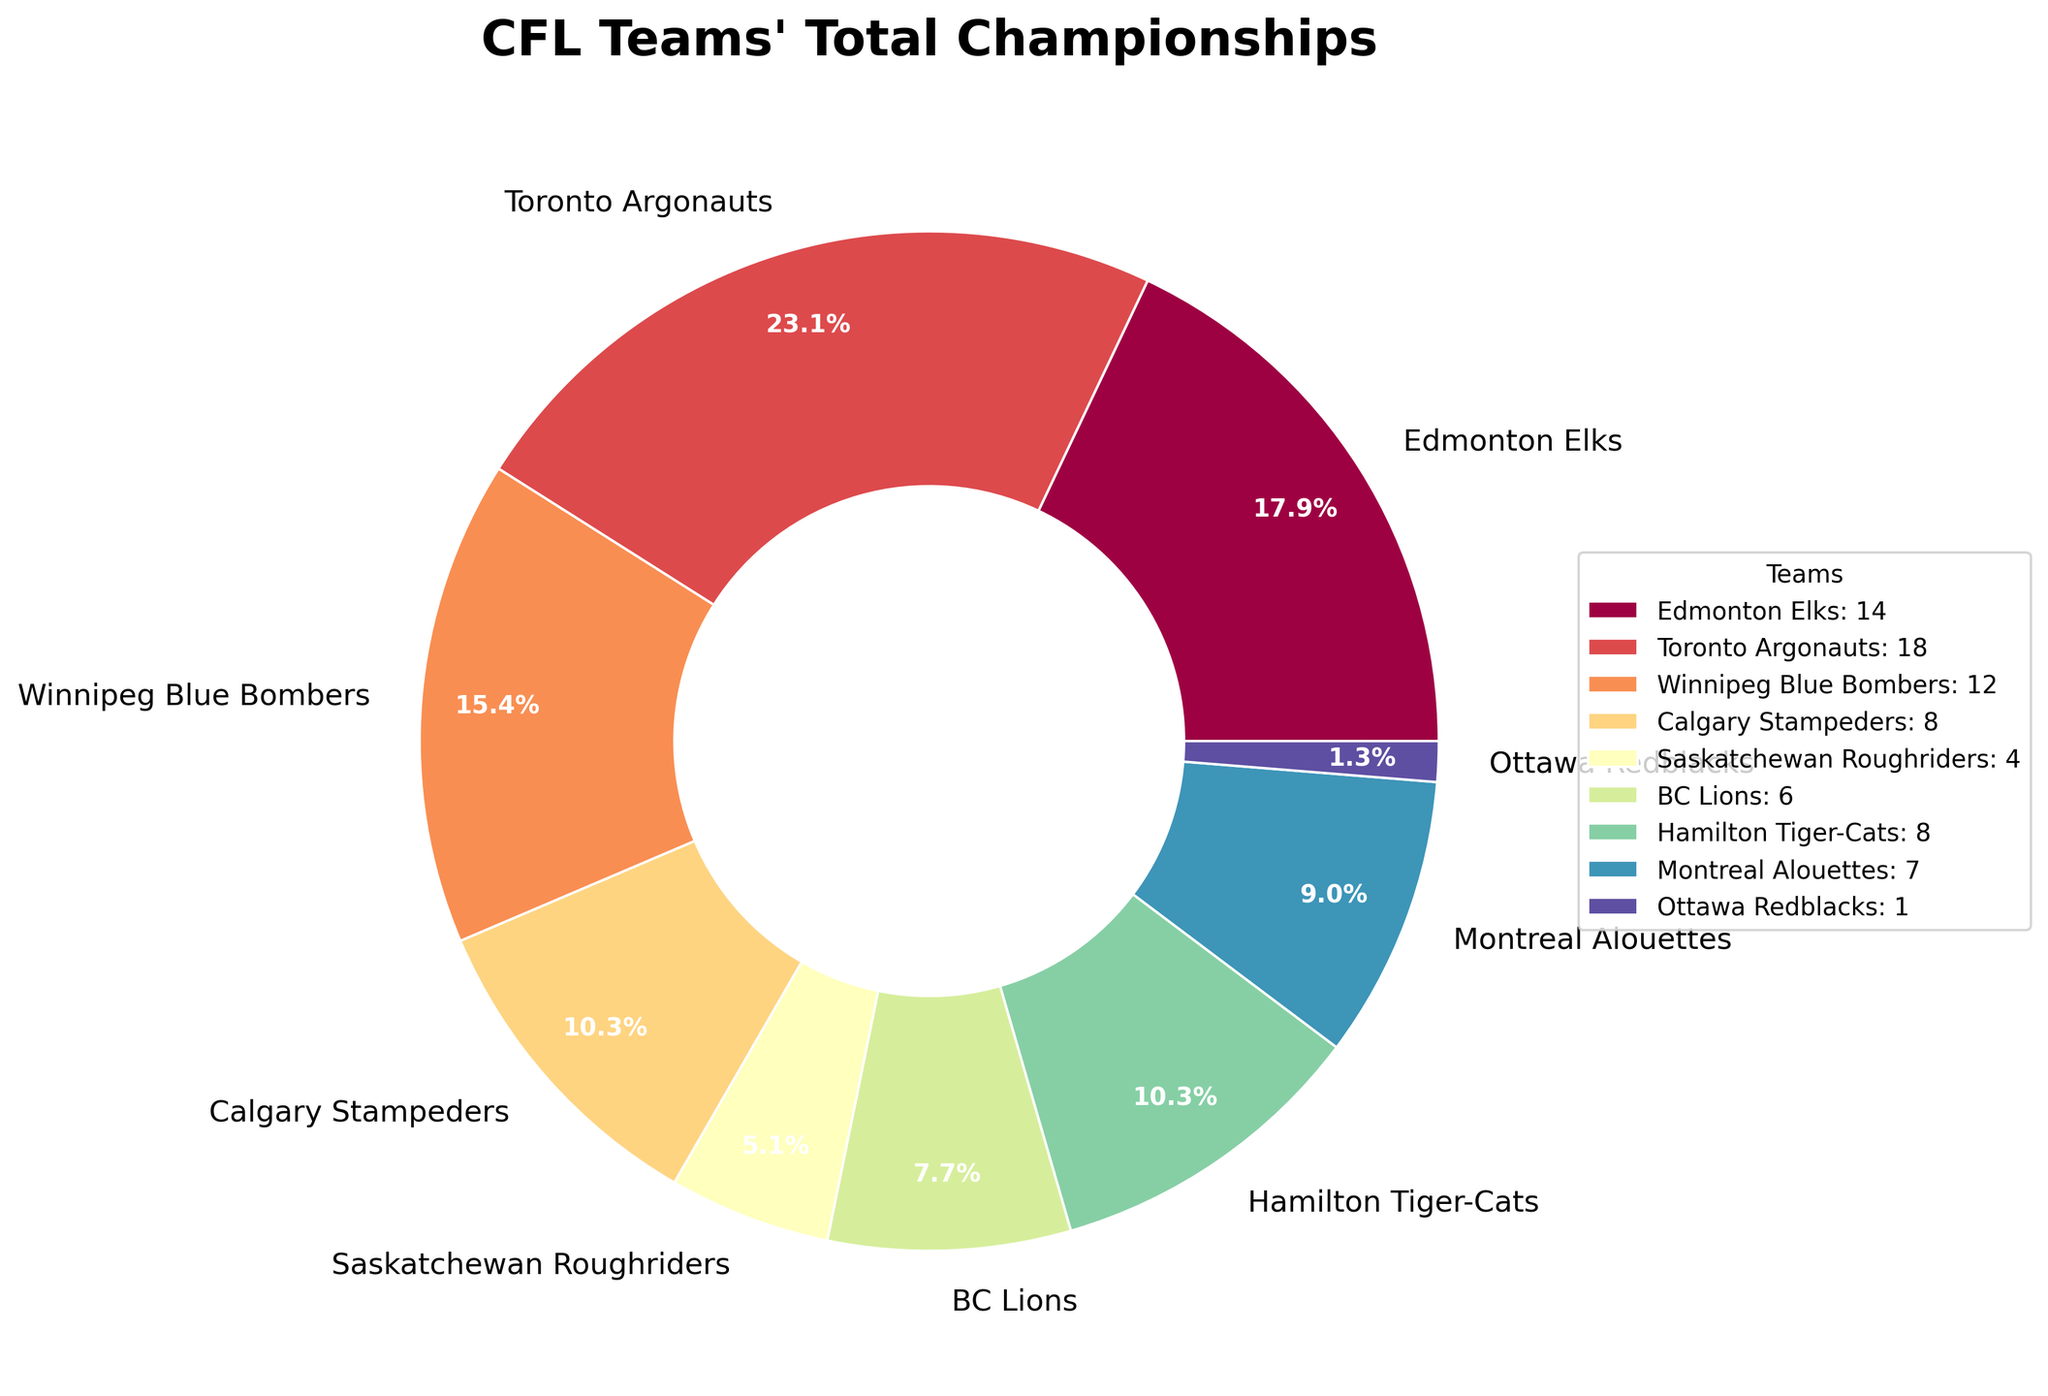Which team has the most championships? The figure indicates that the Toronto Argonauts have the largest slice of the pie, representing the highest number of championships.
Answer: Toronto Argonauts How many championships do the Edmonton Elks and Winnipeg Blue Bombers have combined? The Edmonton Elks have 14 championships and the Winnipeg Blue Bombers have 12 championships. Summing them gives 14 + 12 = 26 championships.
Answer: 26 Which team has fewer championships: the BC Lions or the Montreal Alouettes? By comparing the slices, we see that the BC Lions have 6 championships while the Montreal Alouettes have 7 championships. Therefore, the BC Lions have fewer championships.
Answer: BC Lions What fraction of the total championships is held by the Calgary Stampeders and Hamilton Tiger-Cats together? Calgary Stampeders have 8 championships and Hamilton Tiger-Cats have 8 championships, so combined they have 16. The total number of championships is 78. Therefore, the fraction is 16/78, which simplifies to about 20.5%.
Answer: 20.5% What is the smallest wedge on the pie chart, and which team does it represent? The smallest wedge represents the Ottawa Redblacks, who have only 1 championship.
Answer: Ottawa Redblacks How does the number of championships of the Saskatchewan Roughriders compare to the BC Lions? The Saskatchewan Roughriders have 4 championships, which is 2 fewer than the BC Lions who have 6 championships.
Answer: Saskatchewan Roughriders have fewer If the Toronto Argonauts and Edmonton Elks were combined, what percentage of the total championships would they represent? Toronto Argonauts have 18 championships and Edmonton Elks have 14. Combined, they have 18 + 14 = 32 championships. The total is 78 championships, so the percentage is (32/78) * 100 ≈ 41%.
Answer: 41% Which teams have the same number of championships and what is that number? From the pie chart, Calgary Stampeders and Hamilton Tiger-Cats each have 8 championships.
Answer: Calgary Stampeders and Hamilton Tiger-Cats, 8 